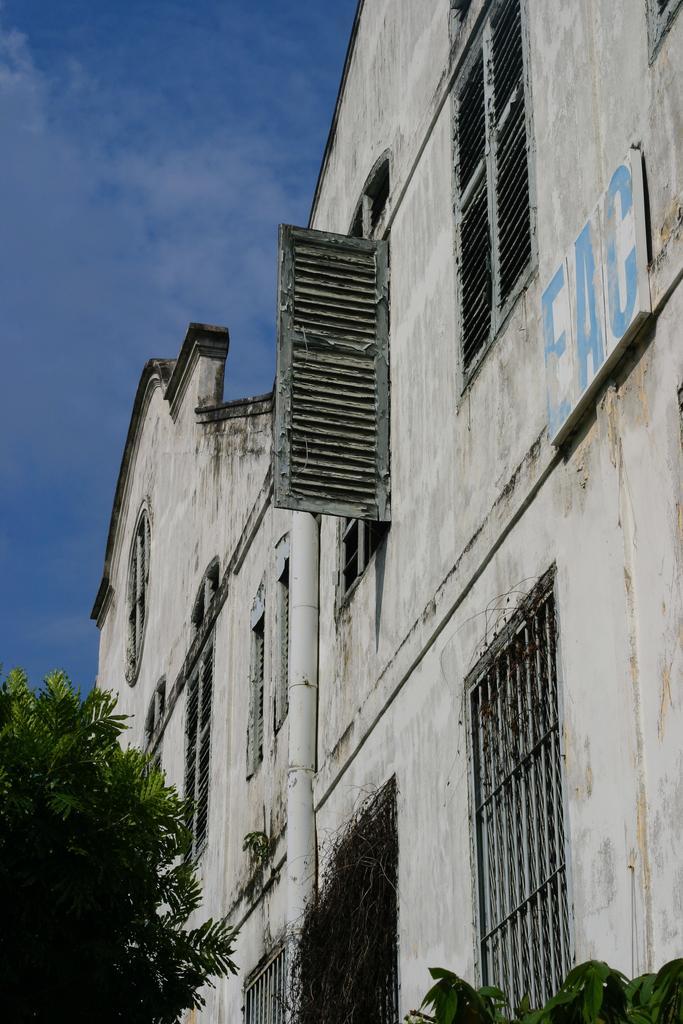How would you summarize this image in a sentence or two? In this image we can see buildings, windows, there is a board with text on it, there are trees, also we can see the sky. 